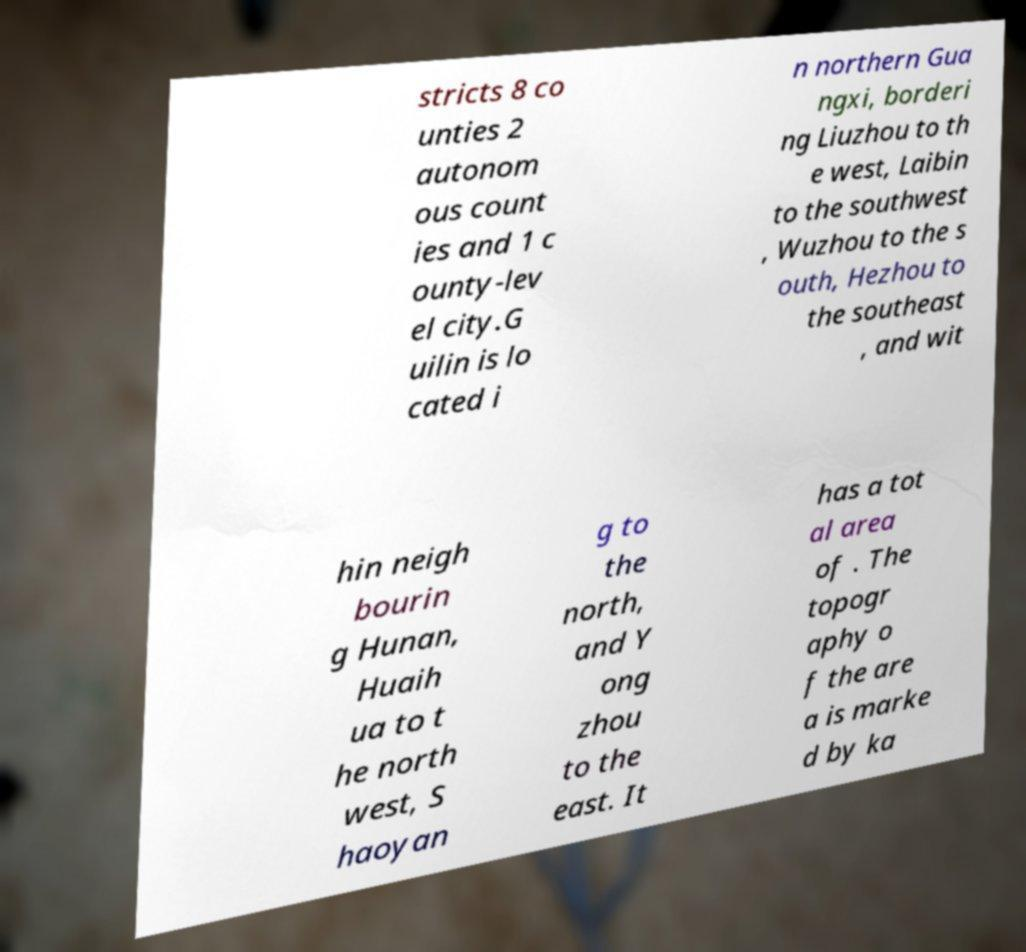For documentation purposes, I need the text within this image transcribed. Could you provide that? stricts 8 co unties 2 autonom ous count ies and 1 c ounty-lev el city.G uilin is lo cated i n northern Gua ngxi, borderi ng Liuzhou to th e west, Laibin to the southwest , Wuzhou to the s outh, Hezhou to the southeast , and wit hin neigh bourin g Hunan, Huaih ua to t he north west, S haoyan g to the north, and Y ong zhou to the east. It has a tot al area of . The topogr aphy o f the are a is marke d by ka 